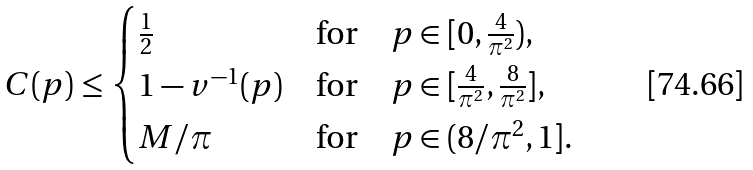Convert formula to latex. <formula><loc_0><loc_0><loc_500><loc_500>C ( p ) \leq \begin{cases} \frac { 1 } { 2 } & \text {for} \quad p \in [ 0 , \frac { 4 } { \pi ^ { 2 } } ) , \\ 1 - v ^ { - 1 } ( p ) & \text {for} \quad p \in [ \frac { 4 } { \pi ^ { 2 } } , \frac { 8 } { \pi ^ { 2 } } ] , \\ M / \pi & \text {for} \quad p \in ( 8 / \pi ^ { 2 } , 1 ] . \\ \end{cases}</formula> 